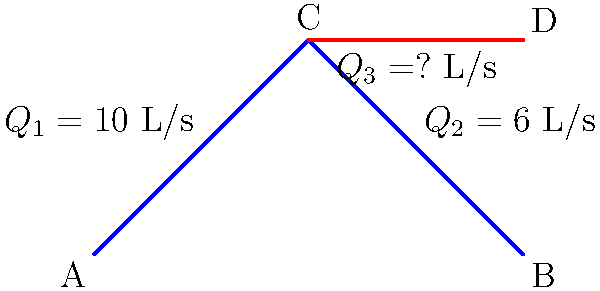В системе труб, показанной на схеме, известны расходы воды $Q_1 = 10$ л/с и $Q_2 = 6$ л/с. Используя принцип сохранения массы, определите расход воды $Q_3$ в трубе CD. Как этот расчет может быть применен при разработке систем водоснабжения для VR/AR симуляций в игровых проектах? Для решения этой задачи применим принцип сохранения массы (или в данном случае, объема жидкости) в точке C:

1) В точке C сумма входящих потоков должна равняться сумме исходящих потоков.

2) Входящий поток: $Q_1 = 10$ л/с

3) Исходящие потоки: $Q_2 = 6$ л/с и $Q_3$ (неизвестный)

4) Составим уравнение баланса:
   $Q_1 = Q_2 + Q_3$

5) Подставим известные значения:
   $10 = 6 + Q_3$

6) Решим уравнение относительно $Q_3$:
   $Q_3 = 10 - 6 = 4$ л/с

В контексте разработки игр, этот принцип может быть использован для создания реалистичных систем водоснабжения в VR/AR симуляциях. Например:
- Моделирование систем пожаротушения в виртуальных зданиях
- Создание интерактивных головоломок, связанных с управлением потоками жидкости
- Симуляция систем охлаждения в виртуальных промышленных объектах

Точный расчет потоков позволит создать более убедительные и образовательные игровые сценарии, повышая уровень погружения пользователя в виртуальную среду.
Answer: $Q_3 = 4$ л/с 